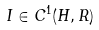<formula> <loc_0><loc_0><loc_500><loc_500>I \in C ^ { 1 } ( H , R )</formula> 